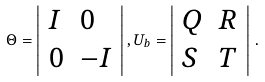Convert formula to latex. <formula><loc_0><loc_0><loc_500><loc_500>\Theta = \left | \begin{array} { l l } { I } & 0 \\ 0 & - { I } \end{array} \right | , U _ { b } = \left | \begin{array} { l l } Q & R \\ S & T \end{array} \right | \, .</formula> 